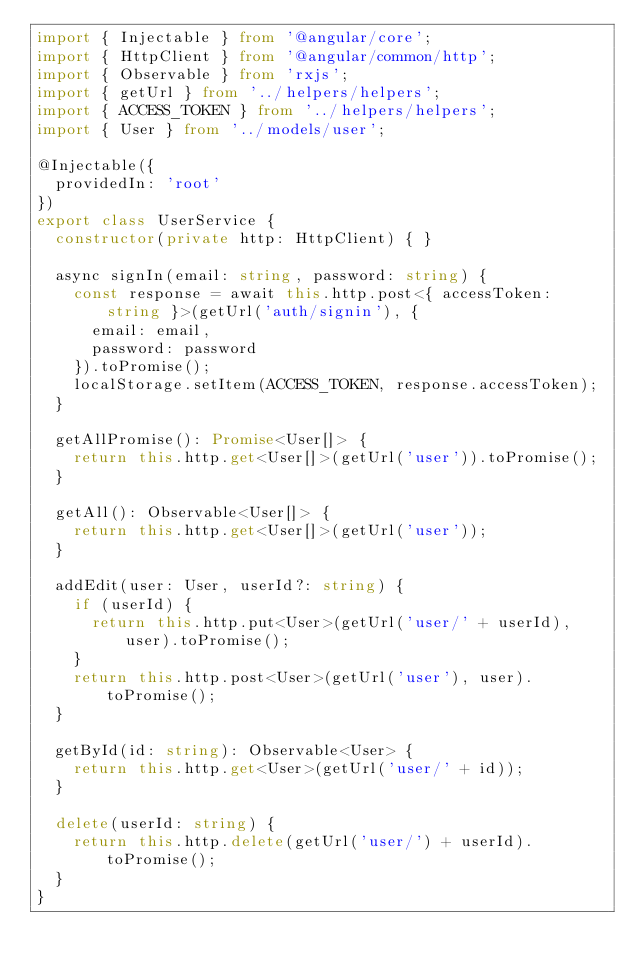Convert code to text. <code><loc_0><loc_0><loc_500><loc_500><_TypeScript_>import { Injectable } from '@angular/core';
import { HttpClient } from '@angular/common/http';
import { Observable } from 'rxjs';
import { getUrl } from '../helpers/helpers';
import { ACCESS_TOKEN } from '../helpers/helpers';
import { User } from '../models/user';

@Injectable({
  providedIn: 'root'
})
export class UserService {
  constructor(private http: HttpClient) { }

  async signIn(email: string, password: string) {
    const response = await this.http.post<{ accessToken: string }>(getUrl('auth/signin'), {
      email: email,
      password: password
    }).toPromise();
    localStorage.setItem(ACCESS_TOKEN, response.accessToken);
  }

  getAllPromise(): Promise<User[]> {
    return this.http.get<User[]>(getUrl('user')).toPromise();
  }

  getAll(): Observable<User[]> {
    return this.http.get<User[]>(getUrl('user'));
  }

  addEdit(user: User, userId?: string) {
    if (userId) {
      return this.http.put<User>(getUrl('user/' + userId), user).toPromise();
    }
    return this.http.post<User>(getUrl('user'), user).toPromise();
  }

  getById(id: string): Observable<User> {
    return this.http.get<User>(getUrl('user/' + id));
  }

  delete(userId: string) {
    return this.http.delete(getUrl('user/') + userId).toPromise();
  }
}</code> 